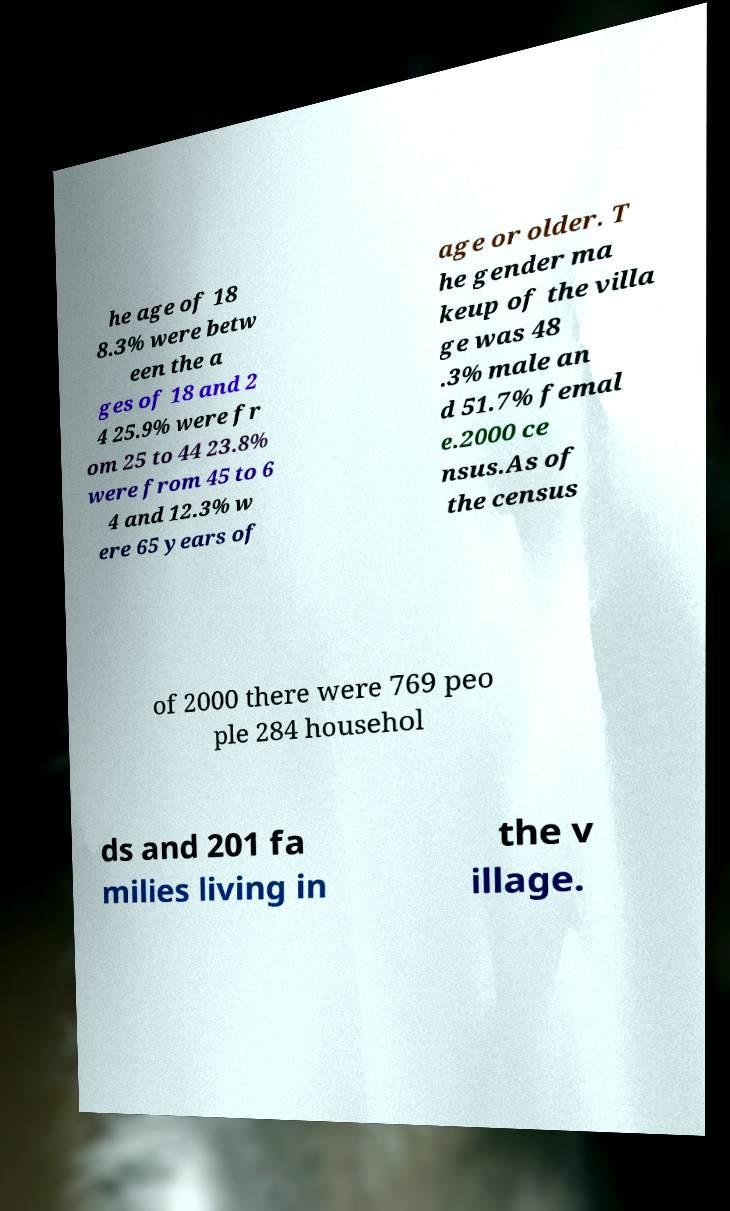Could you assist in decoding the text presented in this image and type it out clearly? he age of 18 8.3% were betw een the a ges of 18 and 2 4 25.9% were fr om 25 to 44 23.8% were from 45 to 6 4 and 12.3% w ere 65 years of age or older. T he gender ma keup of the villa ge was 48 .3% male an d 51.7% femal e.2000 ce nsus.As of the census of 2000 there were 769 peo ple 284 househol ds and 201 fa milies living in the v illage. 